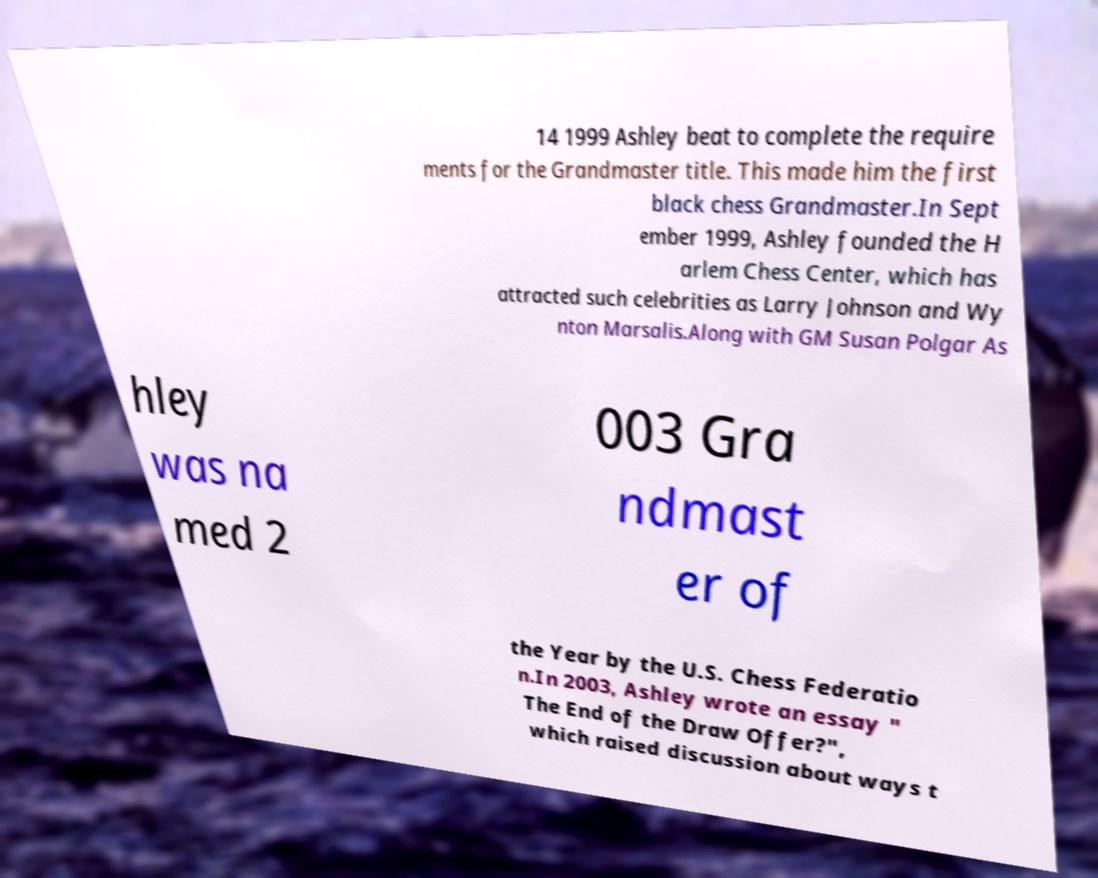What messages or text are displayed in this image? I need them in a readable, typed format. 14 1999 Ashley beat to complete the require ments for the Grandmaster title. This made him the first black chess Grandmaster.In Sept ember 1999, Ashley founded the H arlem Chess Center, which has attracted such celebrities as Larry Johnson and Wy nton Marsalis.Along with GM Susan Polgar As hley was na med 2 003 Gra ndmast er of the Year by the U.S. Chess Federatio n.In 2003, Ashley wrote an essay " The End of the Draw Offer?", which raised discussion about ways t 